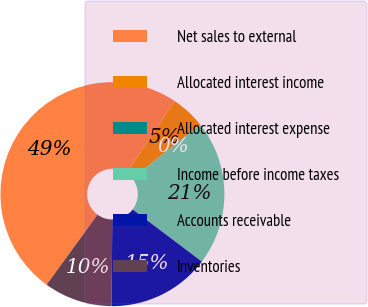<chart> <loc_0><loc_0><loc_500><loc_500><pie_chart><fcel>Net sales to external<fcel>Allocated interest income<fcel>Allocated interest expense<fcel>Income before income taxes<fcel>Accounts receivable<fcel>Inventories<nl><fcel>49.4%<fcel>4.95%<fcel>0.01%<fcel>20.93%<fcel>14.83%<fcel>9.89%<nl></chart> 